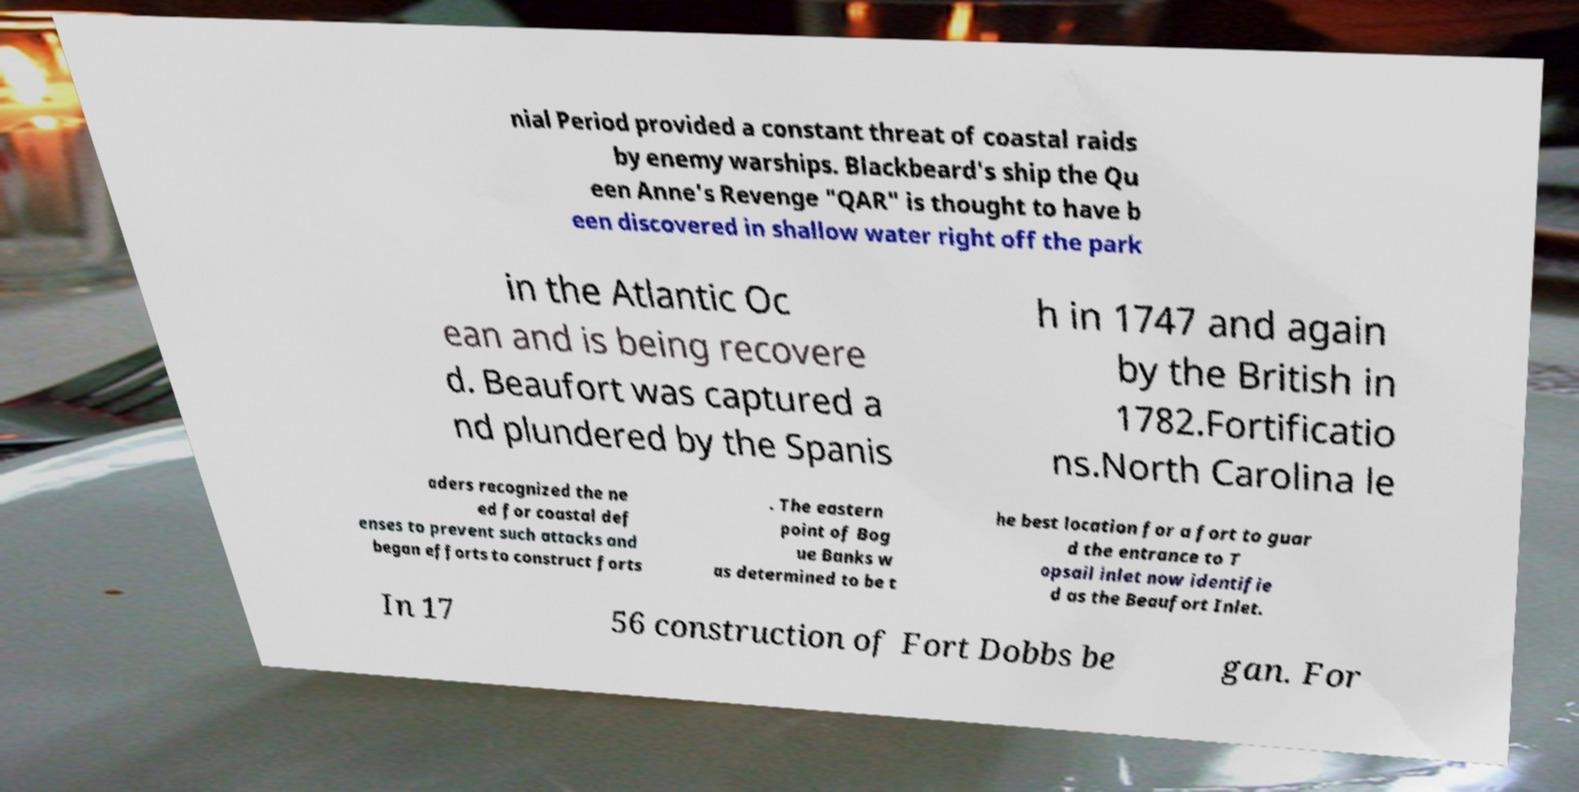Could you assist in decoding the text presented in this image and type it out clearly? nial Period provided a constant threat of coastal raids by enemy warships. Blackbeard's ship the Qu een Anne's Revenge "QAR" is thought to have b een discovered in shallow water right off the park in the Atlantic Oc ean and is being recovere d. Beaufort was captured a nd plundered by the Spanis h in 1747 and again by the British in 1782.Fortificatio ns.North Carolina le aders recognized the ne ed for coastal def enses to prevent such attacks and began efforts to construct forts . The eastern point of Bog ue Banks w as determined to be t he best location for a fort to guar d the entrance to T opsail inlet now identifie d as the Beaufort Inlet. In 17 56 construction of Fort Dobbs be gan. For 